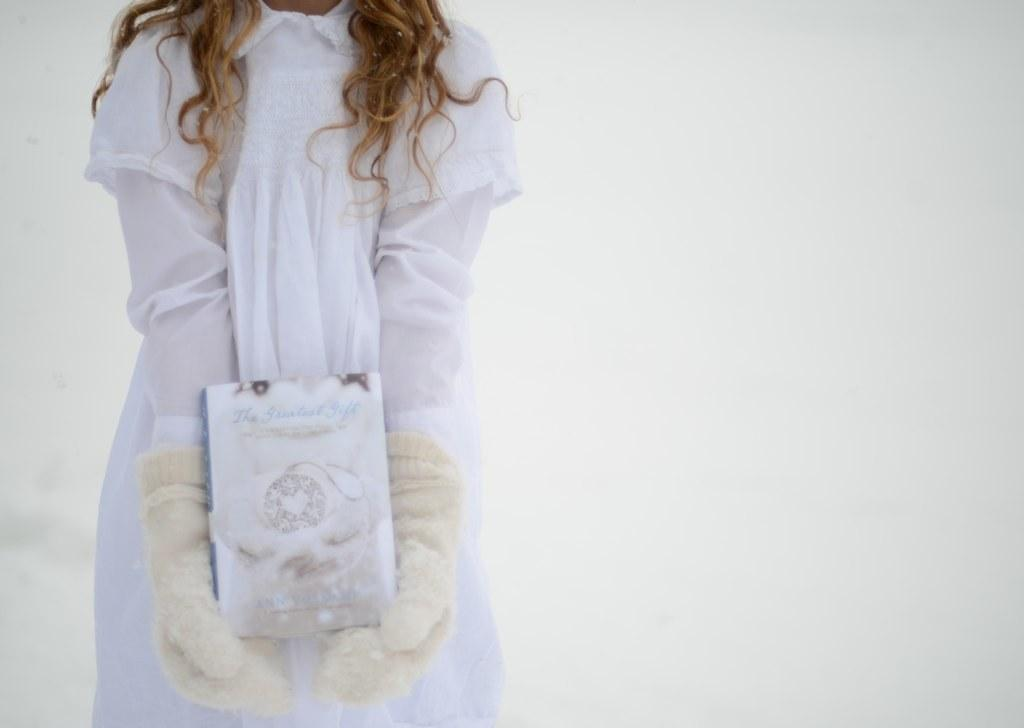Who is the main subject in the image? There is a woman in the image. What is the woman wearing? The woman is wearing a white dress and gloves on her hands. What is the woman holding in her hands? The woman is standing and holding a box in her hands. What is the color of the background in the image? The background of the image is white. What type of baseball play is the woman performing in the image? There is no baseball play or any reference to baseball in the image. 